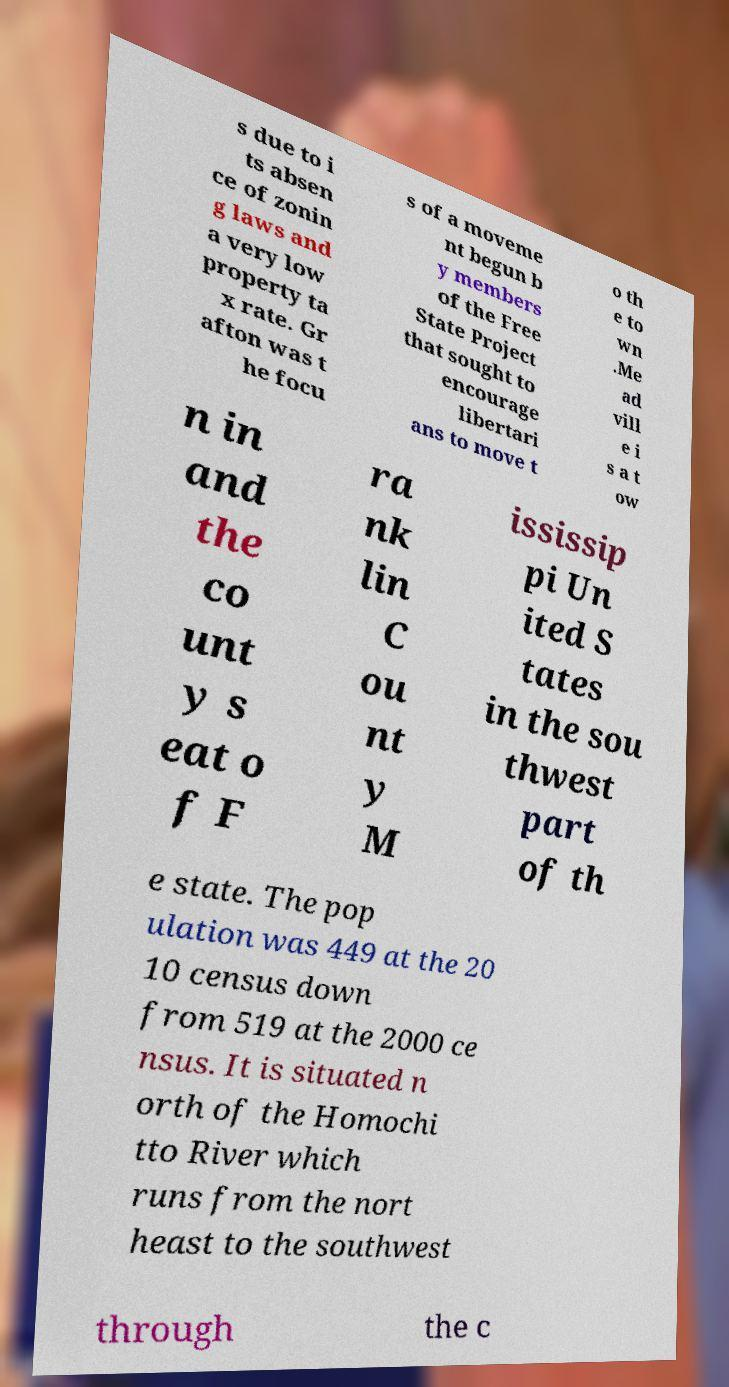Could you extract and type out the text from this image? s due to i ts absen ce of zonin g laws and a very low property ta x rate. Gr afton was t he focu s of a moveme nt begun b y members of the Free State Project that sought to encourage libertari ans to move t o th e to wn .Me ad vill e i s a t ow n in and the co unt y s eat o f F ra nk lin C ou nt y M ississip pi Un ited S tates in the sou thwest part of th e state. The pop ulation was 449 at the 20 10 census down from 519 at the 2000 ce nsus. It is situated n orth of the Homochi tto River which runs from the nort heast to the southwest through the c 